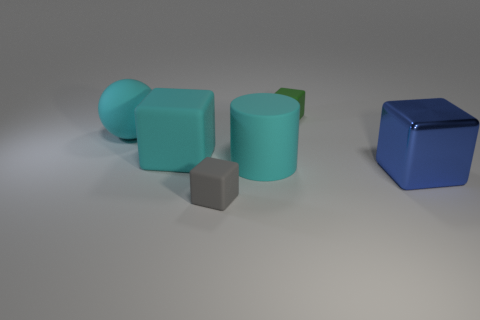Are there any other things that are the same material as the blue object?
Your answer should be very brief. No. What is the material of the block that is both behind the big shiny block and left of the small green matte cube?
Make the answer very short. Rubber. What is the size of the thing that is to the right of the small rubber object behind the cube right of the green matte object?
Ensure brevity in your answer.  Large. There is a green matte object; does it have the same shape as the big cyan rubber thing right of the gray cube?
Provide a succinct answer. No. How many objects are both right of the cylinder and left of the green object?
Offer a very short reply. 0. What number of blue objects are small matte cubes or large shiny objects?
Your answer should be very brief. 1. There is a cube that is in front of the blue thing; does it have the same color as the rubber object that is behind the rubber ball?
Offer a terse response. No. There is a ball in front of the tiny object that is behind the big cyan rubber cylinder behind the metal object; what color is it?
Your answer should be very brief. Cyan. Is there a matte sphere behind the small block that is behind the sphere?
Provide a succinct answer. No. There is a tiny rubber object behind the large blue block; is it the same shape as the gray rubber object?
Offer a very short reply. Yes. 